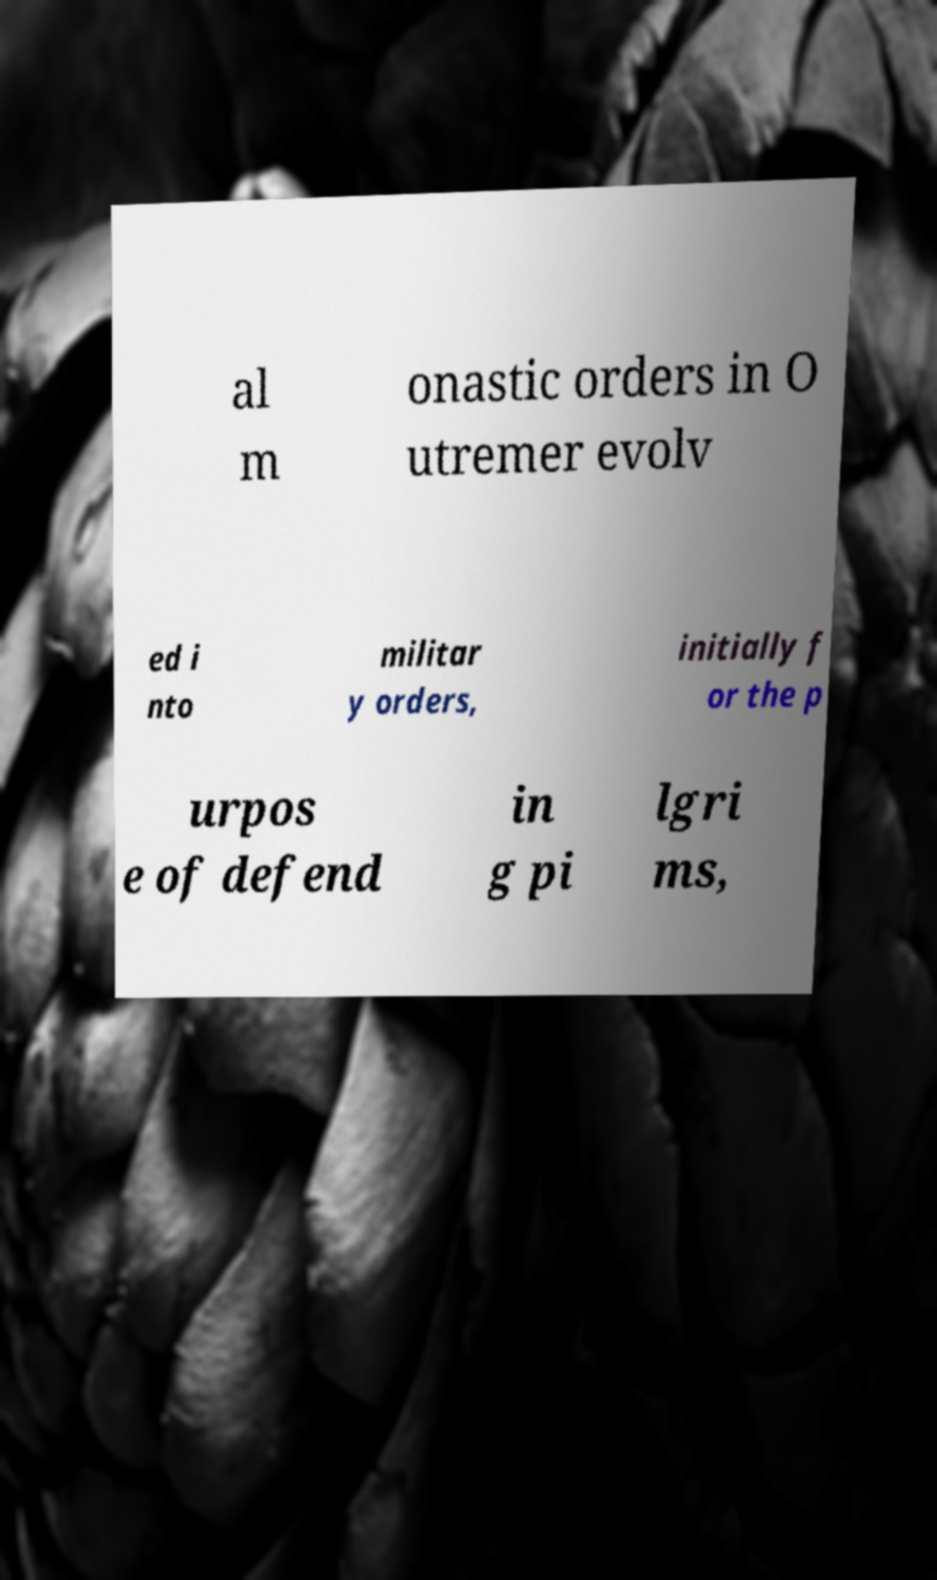There's text embedded in this image that I need extracted. Can you transcribe it verbatim? al m onastic orders in O utremer evolv ed i nto militar y orders, initially f or the p urpos e of defend in g pi lgri ms, 